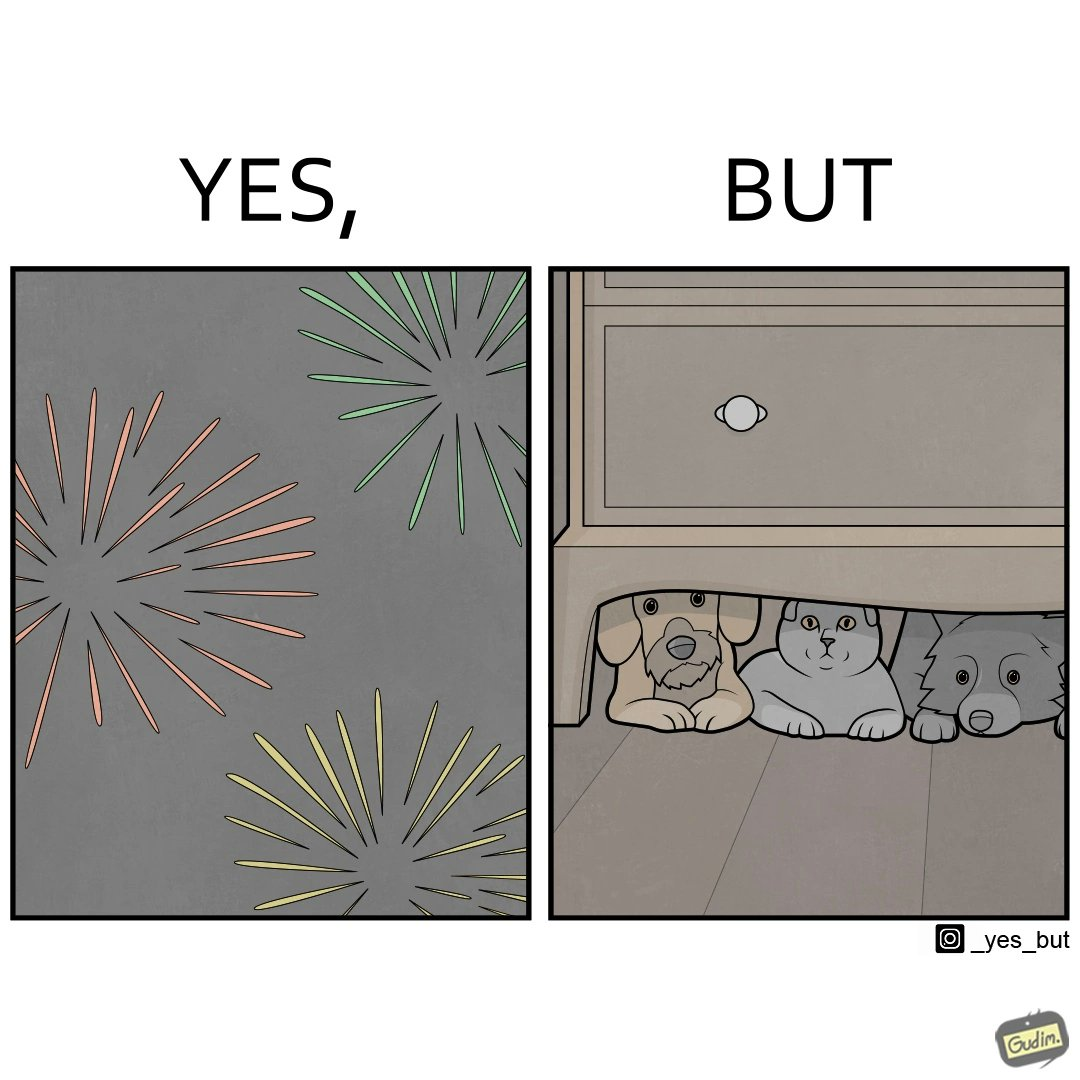Describe what you see in this image. The image is satirical because while firecrackers in the sky look pretty, not everyone likes them. Animals are very scared of the firecrackers. 